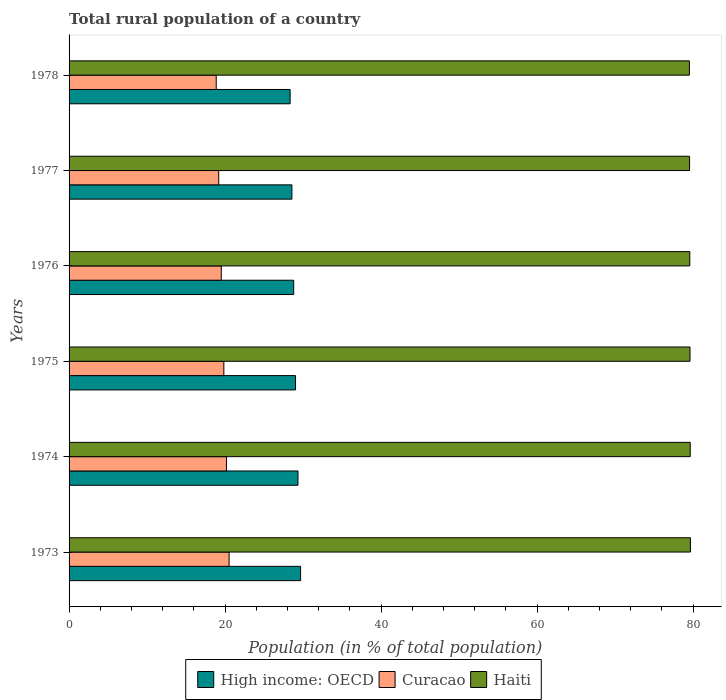How many groups of bars are there?
Provide a succinct answer. 6. Are the number of bars per tick equal to the number of legend labels?
Your response must be concise. Yes. Are the number of bars on each tick of the Y-axis equal?
Make the answer very short. Yes. What is the label of the 1st group of bars from the top?
Give a very brief answer. 1978. In how many cases, is the number of bars for a given year not equal to the number of legend labels?
Make the answer very short. 0. What is the rural population in Curacao in 1978?
Make the answer very short. 18.86. Across all years, what is the maximum rural population in High income: OECD?
Offer a very short reply. 29.68. Across all years, what is the minimum rural population in High income: OECD?
Your answer should be compact. 28.34. In which year was the rural population in Haiti maximum?
Provide a succinct answer. 1973. In which year was the rural population in High income: OECD minimum?
Your response must be concise. 1978. What is the total rural population in Curacao in the graph?
Make the answer very short. 118.08. What is the difference between the rural population in Haiti in 1973 and that in 1975?
Your answer should be very brief. 0.05. What is the difference between the rural population in Curacao in 1977 and the rural population in High income: OECD in 1975?
Give a very brief answer. -9.85. What is the average rural population in High income: OECD per year?
Your response must be concise. 28.96. In the year 1975, what is the difference between the rural population in Haiti and rural population in High income: OECD?
Keep it short and to the point. 50.57. In how many years, is the rural population in Curacao greater than 60 %?
Provide a succinct answer. 0. What is the ratio of the rural population in Curacao in 1975 to that in 1978?
Offer a very short reply. 1.05. Is the rural population in Haiti in 1973 less than that in 1975?
Your response must be concise. No. Is the difference between the rural population in Haiti in 1976 and 1978 greater than the difference between the rural population in High income: OECD in 1976 and 1978?
Provide a short and direct response. No. What is the difference between the highest and the second highest rural population in Curacao?
Your answer should be very brief. 0.34. What is the difference between the highest and the lowest rural population in Curacao?
Provide a succinct answer. 1.65. What does the 2nd bar from the top in 1975 represents?
Offer a very short reply. Curacao. What does the 2nd bar from the bottom in 1973 represents?
Give a very brief answer. Curacao. How many bars are there?
Make the answer very short. 18. Does the graph contain any zero values?
Offer a terse response. No. How many legend labels are there?
Make the answer very short. 3. What is the title of the graph?
Provide a succinct answer. Total rural population of a country. What is the label or title of the X-axis?
Your answer should be very brief. Population (in % of total population). What is the Population (in % of total population) in High income: OECD in 1973?
Provide a short and direct response. 29.68. What is the Population (in % of total population) in Curacao in 1973?
Provide a short and direct response. 20.51. What is the Population (in % of total population) in Haiti in 1973?
Provide a short and direct response. 79.65. What is the Population (in % of total population) of High income: OECD in 1974?
Make the answer very short. 29.34. What is the Population (in % of total population) in Curacao in 1974?
Your response must be concise. 20.17. What is the Population (in % of total population) of Haiti in 1974?
Provide a short and direct response. 79.62. What is the Population (in % of total population) of High income: OECD in 1975?
Make the answer very short. 29.03. What is the Population (in % of total population) of Curacao in 1975?
Your answer should be very brief. 19.84. What is the Population (in % of total population) in Haiti in 1975?
Your answer should be compact. 79.6. What is the Population (in % of total population) of High income: OECD in 1976?
Give a very brief answer. 28.79. What is the Population (in % of total population) of Curacao in 1976?
Offer a very short reply. 19.51. What is the Population (in % of total population) in Haiti in 1976?
Keep it short and to the point. 79.57. What is the Population (in % of total population) in High income: OECD in 1977?
Your response must be concise. 28.56. What is the Population (in % of total population) of Curacao in 1977?
Your answer should be compact. 19.18. What is the Population (in % of total population) in Haiti in 1977?
Your answer should be very brief. 79.54. What is the Population (in % of total population) in High income: OECD in 1978?
Offer a very short reply. 28.34. What is the Population (in % of total population) in Curacao in 1978?
Ensure brevity in your answer.  18.86. What is the Population (in % of total population) of Haiti in 1978?
Keep it short and to the point. 79.51. Across all years, what is the maximum Population (in % of total population) in High income: OECD?
Make the answer very short. 29.68. Across all years, what is the maximum Population (in % of total population) in Curacao?
Ensure brevity in your answer.  20.51. Across all years, what is the maximum Population (in % of total population) in Haiti?
Ensure brevity in your answer.  79.65. Across all years, what is the minimum Population (in % of total population) in High income: OECD?
Make the answer very short. 28.34. Across all years, what is the minimum Population (in % of total population) of Curacao?
Keep it short and to the point. 18.86. Across all years, what is the minimum Population (in % of total population) of Haiti?
Ensure brevity in your answer.  79.51. What is the total Population (in % of total population) of High income: OECD in the graph?
Offer a terse response. 173.75. What is the total Population (in % of total population) of Curacao in the graph?
Provide a succinct answer. 118.08. What is the total Population (in % of total population) in Haiti in the graph?
Offer a terse response. 477.49. What is the difference between the Population (in % of total population) in High income: OECD in 1973 and that in 1974?
Make the answer very short. 0.34. What is the difference between the Population (in % of total population) of Curacao in 1973 and that in 1974?
Keep it short and to the point. 0.34. What is the difference between the Population (in % of total population) in Haiti in 1973 and that in 1974?
Provide a short and direct response. 0.03. What is the difference between the Population (in % of total population) of High income: OECD in 1973 and that in 1975?
Make the answer very short. 0.65. What is the difference between the Population (in % of total population) of Curacao in 1973 and that in 1975?
Offer a terse response. 0.67. What is the difference between the Population (in % of total population) in Haiti in 1973 and that in 1975?
Keep it short and to the point. 0.05. What is the difference between the Population (in % of total population) of High income: OECD in 1973 and that in 1976?
Offer a terse response. 0.89. What is the difference between the Population (in % of total population) of Curacao in 1973 and that in 1976?
Offer a very short reply. 1. What is the difference between the Population (in % of total population) of Haiti in 1973 and that in 1976?
Keep it short and to the point. 0.08. What is the difference between the Population (in % of total population) in High income: OECD in 1973 and that in 1977?
Provide a short and direct response. 1.11. What is the difference between the Population (in % of total population) in Curacao in 1973 and that in 1977?
Ensure brevity in your answer.  1.33. What is the difference between the Population (in % of total population) of Haiti in 1973 and that in 1977?
Your answer should be compact. 0.11. What is the difference between the Population (in % of total population) of High income: OECD in 1973 and that in 1978?
Your response must be concise. 1.34. What is the difference between the Population (in % of total population) of Curacao in 1973 and that in 1978?
Offer a terse response. 1.65. What is the difference between the Population (in % of total population) in Haiti in 1973 and that in 1978?
Your answer should be very brief. 0.14. What is the difference between the Population (in % of total population) in High income: OECD in 1974 and that in 1975?
Your answer should be compact. 0.31. What is the difference between the Population (in % of total population) of Curacao in 1974 and that in 1975?
Ensure brevity in your answer.  0.33. What is the difference between the Population (in % of total population) of Haiti in 1974 and that in 1975?
Ensure brevity in your answer.  0.03. What is the difference between the Population (in % of total population) in High income: OECD in 1974 and that in 1976?
Offer a terse response. 0.55. What is the difference between the Population (in % of total population) in Curacao in 1974 and that in 1976?
Provide a short and direct response. 0.66. What is the difference between the Population (in % of total population) in Haiti in 1974 and that in 1976?
Keep it short and to the point. 0.05. What is the difference between the Population (in % of total population) in High income: OECD in 1974 and that in 1977?
Provide a short and direct response. 0.78. What is the difference between the Population (in % of total population) of Haiti in 1974 and that in 1977?
Keep it short and to the point. 0.08. What is the difference between the Population (in % of total population) in High income: OECD in 1974 and that in 1978?
Offer a terse response. 1.01. What is the difference between the Population (in % of total population) of Curacao in 1974 and that in 1978?
Offer a terse response. 1.31. What is the difference between the Population (in % of total population) in Haiti in 1974 and that in 1978?
Your response must be concise. 0.11. What is the difference between the Population (in % of total population) in High income: OECD in 1975 and that in 1976?
Provide a succinct answer. 0.24. What is the difference between the Population (in % of total population) of Curacao in 1975 and that in 1976?
Keep it short and to the point. 0.33. What is the difference between the Population (in % of total population) in Haiti in 1975 and that in 1976?
Your answer should be compact. 0.03. What is the difference between the Population (in % of total population) in High income: OECD in 1975 and that in 1977?
Your answer should be very brief. 0.46. What is the difference between the Population (in % of total population) in Curacao in 1975 and that in 1977?
Offer a terse response. 0.66. What is the difference between the Population (in % of total population) in Haiti in 1975 and that in 1977?
Keep it short and to the point. 0.06. What is the difference between the Population (in % of total population) of High income: OECD in 1975 and that in 1978?
Give a very brief answer. 0.69. What is the difference between the Population (in % of total population) of Curacao in 1975 and that in 1978?
Your answer should be compact. 0.98. What is the difference between the Population (in % of total population) of Haiti in 1975 and that in 1978?
Give a very brief answer. 0.08. What is the difference between the Population (in % of total population) of High income: OECD in 1976 and that in 1977?
Your response must be concise. 0.23. What is the difference between the Population (in % of total population) of Curacao in 1976 and that in 1977?
Your answer should be very brief. 0.33. What is the difference between the Population (in % of total population) of Haiti in 1976 and that in 1977?
Ensure brevity in your answer.  0.03. What is the difference between the Population (in % of total population) of High income: OECD in 1976 and that in 1978?
Your answer should be very brief. 0.46. What is the difference between the Population (in % of total population) of Curacao in 1976 and that in 1978?
Make the answer very short. 0.65. What is the difference between the Population (in % of total population) of Haiti in 1976 and that in 1978?
Your response must be concise. 0.06. What is the difference between the Population (in % of total population) of High income: OECD in 1977 and that in 1978?
Offer a terse response. 0.23. What is the difference between the Population (in % of total population) in Curacao in 1977 and that in 1978?
Offer a very short reply. 0.32. What is the difference between the Population (in % of total population) of Haiti in 1977 and that in 1978?
Ensure brevity in your answer.  0.03. What is the difference between the Population (in % of total population) in High income: OECD in 1973 and the Population (in % of total population) in Curacao in 1974?
Offer a terse response. 9.51. What is the difference between the Population (in % of total population) of High income: OECD in 1973 and the Population (in % of total population) of Haiti in 1974?
Provide a succinct answer. -49.94. What is the difference between the Population (in % of total population) in Curacao in 1973 and the Population (in % of total population) in Haiti in 1974?
Ensure brevity in your answer.  -59.11. What is the difference between the Population (in % of total population) in High income: OECD in 1973 and the Population (in % of total population) in Curacao in 1975?
Keep it short and to the point. 9.84. What is the difference between the Population (in % of total population) in High income: OECD in 1973 and the Population (in % of total population) in Haiti in 1975?
Your answer should be very brief. -49.92. What is the difference between the Population (in % of total population) of Curacao in 1973 and the Population (in % of total population) of Haiti in 1975?
Offer a very short reply. -59.08. What is the difference between the Population (in % of total population) in High income: OECD in 1973 and the Population (in % of total population) in Curacao in 1976?
Your response must be concise. 10.17. What is the difference between the Population (in % of total population) in High income: OECD in 1973 and the Population (in % of total population) in Haiti in 1976?
Ensure brevity in your answer.  -49.89. What is the difference between the Population (in % of total population) in Curacao in 1973 and the Population (in % of total population) in Haiti in 1976?
Your response must be concise. -59.06. What is the difference between the Population (in % of total population) of High income: OECD in 1973 and the Population (in % of total population) of Curacao in 1977?
Ensure brevity in your answer.  10.5. What is the difference between the Population (in % of total population) in High income: OECD in 1973 and the Population (in % of total population) in Haiti in 1977?
Make the answer very short. -49.86. What is the difference between the Population (in % of total population) in Curacao in 1973 and the Population (in % of total population) in Haiti in 1977?
Offer a very short reply. -59.03. What is the difference between the Population (in % of total population) in High income: OECD in 1973 and the Population (in % of total population) in Curacao in 1978?
Provide a short and direct response. 10.82. What is the difference between the Population (in % of total population) in High income: OECD in 1973 and the Population (in % of total population) in Haiti in 1978?
Ensure brevity in your answer.  -49.83. What is the difference between the Population (in % of total population) of Curacao in 1973 and the Population (in % of total population) of Haiti in 1978?
Ensure brevity in your answer.  -59. What is the difference between the Population (in % of total population) in High income: OECD in 1974 and the Population (in % of total population) in Curacao in 1975?
Your response must be concise. 9.5. What is the difference between the Population (in % of total population) in High income: OECD in 1974 and the Population (in % of total population) in Haiti in 1975?
Your answer should be very brief. -50.25. What is the difference between the Population (in % of total population) in Curacao in 1974 and the Population (in % of total population) in Haiti in 1975?
Ensure brevity in your answer.  -59.42. What is the difference between the Population (in % of total population) in High income: OECD in 1974 and the Population (in % of total population) in Curacao in 1976?
Provide a short and direct response. 9.83. What is the difference between the Population (in % of total population) in High income: OECD in 1974 and the Population (in % of total population) in Haiti in 1976?
Your answer should be very brief. -50.23. What is the difference between the Population (in % of total population) in Curacao in 1974 and the Population (in % of total population) in Haiti in 1976?
Your response must be concise. -59.4. What is the difference between the Population (in % of total population) in High income: OECD in 1974 and the Population (in % of total population) in Curacao in 1977?
Give a very brief answer. 10.16. What is the difference between the Population (in % of total population) in High income: OECD in 1974 and the Population (in % of total population) in Haiti in 1977?
Offer a terse response. -50.2. What is the difference between the Population (in % of total population) in Curacao in 1974 and the Population (in % of total population) in Haiti in 1977?
Give a very brief answer. -59.37. What is the difference between the Population (in % of total population) in High income: OECD in 1974 and the Population (in % of total population) in Curacao in 1978?
Provide a succinct answer. 10.48. What is the difference between the Population (in % of total population) in High income: OECD in 1974 and the Population (in % of total population) in Haiti in 1978?
Offer a very short reply. -50.17. What is the difference between the Population (in % of total population) of Curacao in 1974 and the Population (in % of total population) of Haiti in 1978?
Make the answer very short. -59.34. What is the difference between the Population (in % of total population) in High income: OECD in 1975 and the Population (in % of total population) in Curacao in 1976?
Keep it short and to the point. 9.52. What is the difference between the Population (in % of total population) in High income: OECD in 1975 and the Population (in % of total population) in Haiti in 1976?
Offer a very short reply. -50.54. What is the difference between the Population (in % of total population) of Curacao in 1975 and the Population (in % of total population) of Haiti in 1976?
Provide a short and direct response. -59.73. What is the difference between the Population (in % of total population) in High income: OECD in 1975 and the Population (in % of total population) in Curacao in 1977?
Your response must be concise. 9.85. What is the difference between the Population (in % of total population) in High income: OECD in 1975 and the Population (in % of total population) in Haiti in 1977?
Your answer should be compact. -50.51. What is the difference between the Population (in % of total population) of Curacao in 1975 and the Population (in % of total population) of Haiti in 1977?
Your answer should be compact. -59.7. What is the difference between the Population (in % of total population) of High income: OECD in 1975 and the Population (in % of total population) of Curacao in 1978?
Your response must be concise. 10.17. What is the difference between the Population (in % of total population) in High income: OECD in 1975 and the Population (in % of total population) in Haiti in 1978?
Provide a succinct answer. -50.48. What is the difference between the Population (in % of total population) in Curacao in 1975 and the Population (in % of total population) in Haiti in 1978?
Ensure brevity in your answer.  -59.67. What is the difference between the Population (in % of total population) in High income: OECD in 1976 and the Population (in % of total population) in Curacao in 1977?
Provide a succinct answer. 9.61. What is the difference between the Population (in % of total population) in High income: OECD in 1976 and the Population (in % of total population) in Haiti in 1977?
Your answer should be compact. -50.75. What is the difference between the Population (in % of total population) in Curacao in 1976 and the Population (in % of total population) in Haiti in 1977?
Your response must be concise. -60.03. What is the difference between the Population (in % of total population) of High income: OECD in 1976 and the Population (in % of total population) of Curacao in 1978?
Make the answer very short. 9.93. What is the difference between the Population (in % of total population) in High income: OECD in 1976 and the Population (in % of total population) in Haiti in 1978?
Give a very brief answer. -50.72. What is the difference between the Population (in % of total population) of Curacao in 1976 and the Population (in % of total population) of Haiti in 1978?
Offer a very short reply. -60.01. What is the difference between the Population (in % of total population) in High income: OECD in 1977 and the Population (in % of total population) in Curacao in 1978?
Ensure brevity in your answer.  9.7. What is the difference between the Population (in % of total population) in High income: OECD in 1977 and the Population (in % of total population) in Haiti in 1978?
Offer a very short reply. -50.95. What is the difference between the Population (in % of total population) of Curacao in 1977 and the Population (in % of total population) of Haiti in 1978?
Offer a very short reply. -60.33. What is the average Population (in % of total population) of High income: OECD per year?
Your answer should be very brief. 28.96. What is the average Population (in % of total population) of Curacao per year?
Your answer should be compact. 19.68. What is the average Population (in % of total population) in Haiti per year?
Your answer should be compact. 79.58. In the year 1973, what is the difference between the Population (in % of total population) in High income: OECD and Population (in % of total population) in Curacao?
Your answer should be compact. 9.17. In the year 1973, what is the difference between the Population (in % of total population) of High income: OECD and Population (in % of total population) of Haiti?
Make the answer very short. -49.97. In the year 1973, what is the difference between the Population (in % of total population) of Curacao and Population (in % of total population) of Haiti?
Provide a short and direct response. -59.14. In the year 1974, what is the difference between the Population (in % of total population) in High income: OECD and Population (in % of total population) in Curacao?
Make the answer very short. 9.17. In the year 1974, what is the difference between the Population (in % of total population) of High income: OECD and Population (in % of total population) of Haiti?
Ensure brevity in your answer.  -50.28. In the year 1974, what is the difference between the Population (in % of total population) in Curacao and Population (in % of total population) in Haiti?
Provide a short and direct response. -59.45. In the year 1975, what is the difference between the Population (in % of total population) of High income: OECD and Population (in % of total population) of Curacao?
Ensure brevity in your answer.  9.19. In the year 1975, what is the difference between the Population (in % of total population) in High income: OECD and Population (in % of total population) in Haiti?
Ensure brevity in your answer.  -50.57. In the year 1975, what is the difference between the Population (in % of total population) in Curacao and Population (in % of total population) in Haiti?
Your answer should be very brief. -59.76. In the year 1976, what is the difference between the Population (in % of total population) of High income: OECD and Population (in % of total population) of Curacao?
Provide a short and direct response. 9.28. In the year 1976, what is the difference between the Population (in % of total population) in High income: OECD and Population (in % of total population) in Haiti?
Your answer should be compact. -50.78. In the year 1976, what is the difference between the Population (in % of total population) of Curacao and Population (in % of total population) of Haiti?
Provide a short and direct response. -60.06. In the year 1977, what is the difference between the Population (in % of total population) of High income: OECD and Population (in % of total population) of Curacao?
Keep it short and to the point. 9.38. In the year 1977, what is the difference between the Population (in % of total population) of High income: OECD and Population (in % of total population) of Haiti?
Give a very brief answer. -50.98. In the year 1977, what is the difference between the Population (in % of total population) of Curacao and Population (in % of total population) of Haiti?
Provide a short and direct response. -60.36. In the year 1978, what is the difference between the Population (in % of total population) in High income: OECD and Population (in % of total population) in Curacao?
Your answer should be very brief. 9.47. In the year 1978, what is the difference between the Population (in % of total population) of High income: OECD and Population (in % of total population) of Haiti?
Keep it short and to the point. -51.18. In the year 1978, what is the difference between the Population (in % of total population) in Curacao and Population (in % of total population) in Haiti?
Your answer should be compact. -60.65. What is the ratio of the Population (in % of total population) of High income: OECD in 1973 to that in 1974?
Keep it short and to the point. 1.01. What is the ratio of the Population (in % of total population) in Curacao in 1973 to that in 1974?
Offer a terse response. 1.02. What is the ratio of the Population (in % of total population) of Haiti in 1973 to that in 1974?
Provide a succinct answer. 1. What is the ratio of the Population (in % of total population) of High income: OECD in 1973 to that in 1975?
Ensure brevity in your answer.  1.02. What is the ratio of the Population (in % of total population) in Curacao in 1973 to that in 1975?
Your response must be concise. 1.03. What is the ratio of the Population (in % of total population) of Haiti in 1973 to that in 1975?
Your answer should be very brief. 1. What is the ratio of the Population (in % of total population) of High income: OECD in 1973 to that in 1976?
Provide a succinct answer. 1.03. What is the ratio of the Population (in % of total population) of Curacao in 1973 to that in 1976?
Ensure brevity in your answer.  1.05. What is the ratio of the Population (in % of total population) in Haiti in 1973 to that in 1976?
Your answer should be compact. 1. What is the ratio of the Population (in % of total population) in High income: OECD in 1973 to that in 1977?
Give a very brief answer. 1.04. What is the ratio of the Population (in % of total population) in Curacao in 1973 to that in 1977?
Offer a very short reply. 1.07. What is the ratio of the Population (in % of total population) of Haiti in 1973 to that in 1977?
Provide a succinct answer. 1. What is the ratio of the Population (in % of total population) in High income: OECD in 1973 to that in 1978?
Offer a terse response. 1.05. What is the ratio of the Population (in % of total population) in Curacao in 1973 to that in 1978?
Keep it short and to the point. 1.09. What is the ratio of the Population (in % of total population) of Haiti in 1973 to that in 1978?
Your answer should be compact. 1. What is the ratio of the Population (in % of total population) in High income: OECD in 1974 to that in 1975?
Offer a terse response. 1.01. What is the ratio of the Population (in % of total population) in Curacao in 1974 to that in 1975?
Make the answer very short. 1.02. What is the ratio of the Population (in % of total population) of Haiti in 1974 to that in 1975?
Keep it short and to the point. 1. What is the ratio of the Population (in % of total population) in High income: OECD in 1974 to that in 1976?
Provide a succinct answer. 1.02. What is the ratio of the Population (in % of total population) in Curacao in 1974 to that in 1976?
Your answer should be compact. 1.03. What is the ratio of the Population (in % of total population) of High income: OECD in 1974 to that in 1977?
Ensure brevity in your answer.  1.03. What is the ratio of the Population (in % of total population) of Curacao in 1974 to that in 1977?
Your answer should be compact. 1.05. What is the ratio of the Population (in % of total population) of Haiti in 1974 to that in 1977?
Give a very brief answer. 1. What is the ratio of the Population (in % of total population) of High income: OECD in 1974 to that in 1978?
Give a very brief answer. 1.04. What is the ratio of the Population (in % of total population) in Curacao in 1974 to that in 1978?
Provide a succinct answer. 1.07. What is the ratio of the Population (in % of total population) in High income: OECD in 1975 to that in 1976?
Provide a succinct answer. 1.01. What is the ratio of the Population (in % of total population) of Curacao in 1975 to that in 1976?
Your answer should be compact. 1.02. What is the ratio of the Population (in % of total population) in Haiti in 1975 to that in 1976?
Give a very brief answer. 1. What is the ratio of the Population (in % of total population) in High income: OECD in 1975 to that in 1977?
Give a very brief answer. 1.02. What is the ratio of the Population (in % of total population) in Curacao in 1975 to that in 1977?
Provide a short and direct response. 1.03. What is the ratio of the Population (in % of total population) in Haiti in 1975 to that in 1977?
Your answer should be compact. 1. What is the ratio of the Population (in % of total population) of High income: OECD in 1975 to that in 1978?
Offer a terse response. 1.02. What is the ratio of the Population (in % of total population) of Curacao in 1975 to that in 1978?
Your answer should be very brief. 1.05. What is the ratio of the Population (in % of total population) of High income: OECD in 1976 to that in 1978?
Your answer should be very brief. 1.02. What is the ratio of the Population (in % of total population) in Curacao in 1976 to that in 1978?
Offer a terse response. 1.03. What is the difference between the highest and the second highest Population (in % of total population) of High income: OECD?
Your answer should be compact. 0.34. What is the difference between the highest and the second highest Population (in % of total population) in Curacao?
Make the answer very short. 0.34. What is the difference between the highest and the second highest Population (in % of total population) of Haiti?
Keep it short and to the point. 0.03. What is the difference between the highest and the lowest Population (in % of total population) of High income: OECD?
Provide a short and direct response. 1.34. What is the difference between the highest and the lowest Population (in % of total population) in Curacao?
Provide a short and direct response. 1.65. What is the difference between the highest and the lowest Population (in % of total population) of Haiti?
Offer a terse response. 0.14. 